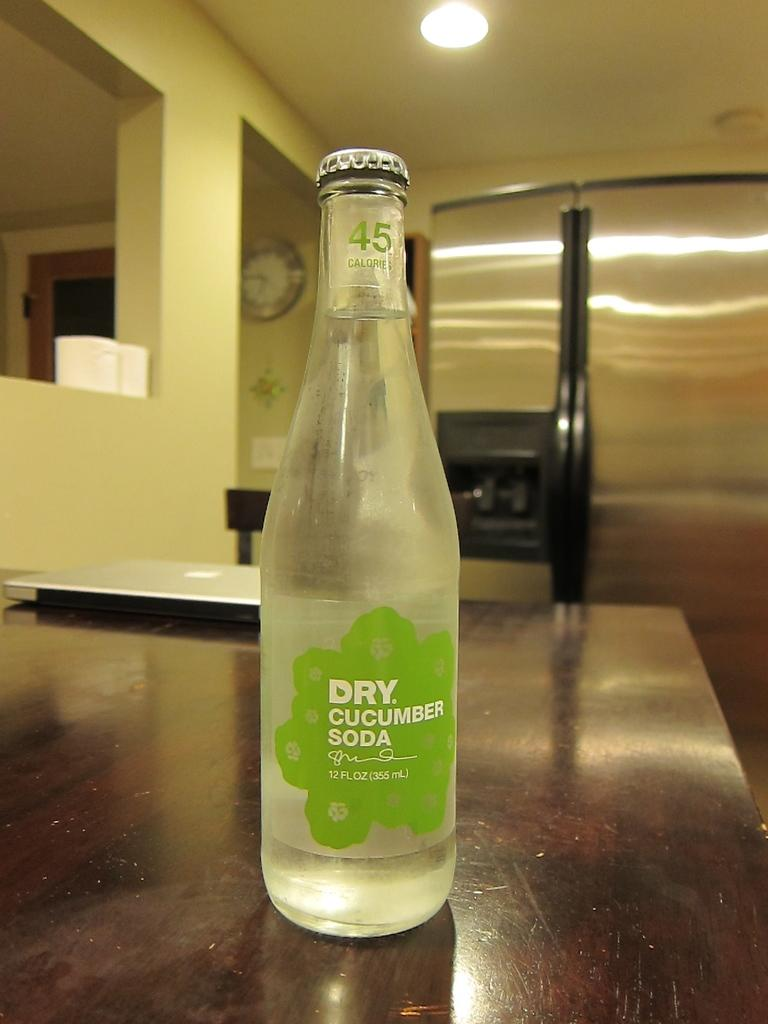<image>
Present a compact description of the photo's key features. A bottle of Dry Cucumber Soda rests on a table. 